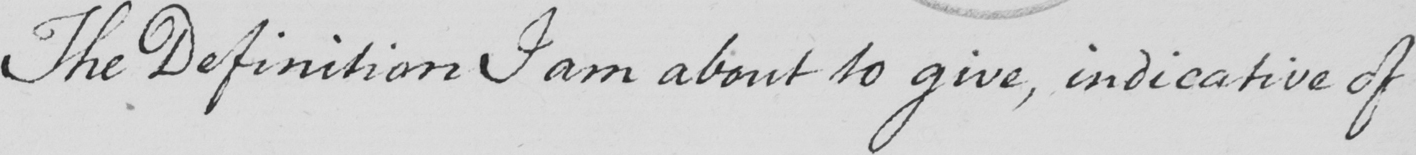Please transcribe the handwritten text in this image. The Definition I am about to give , indicative of 